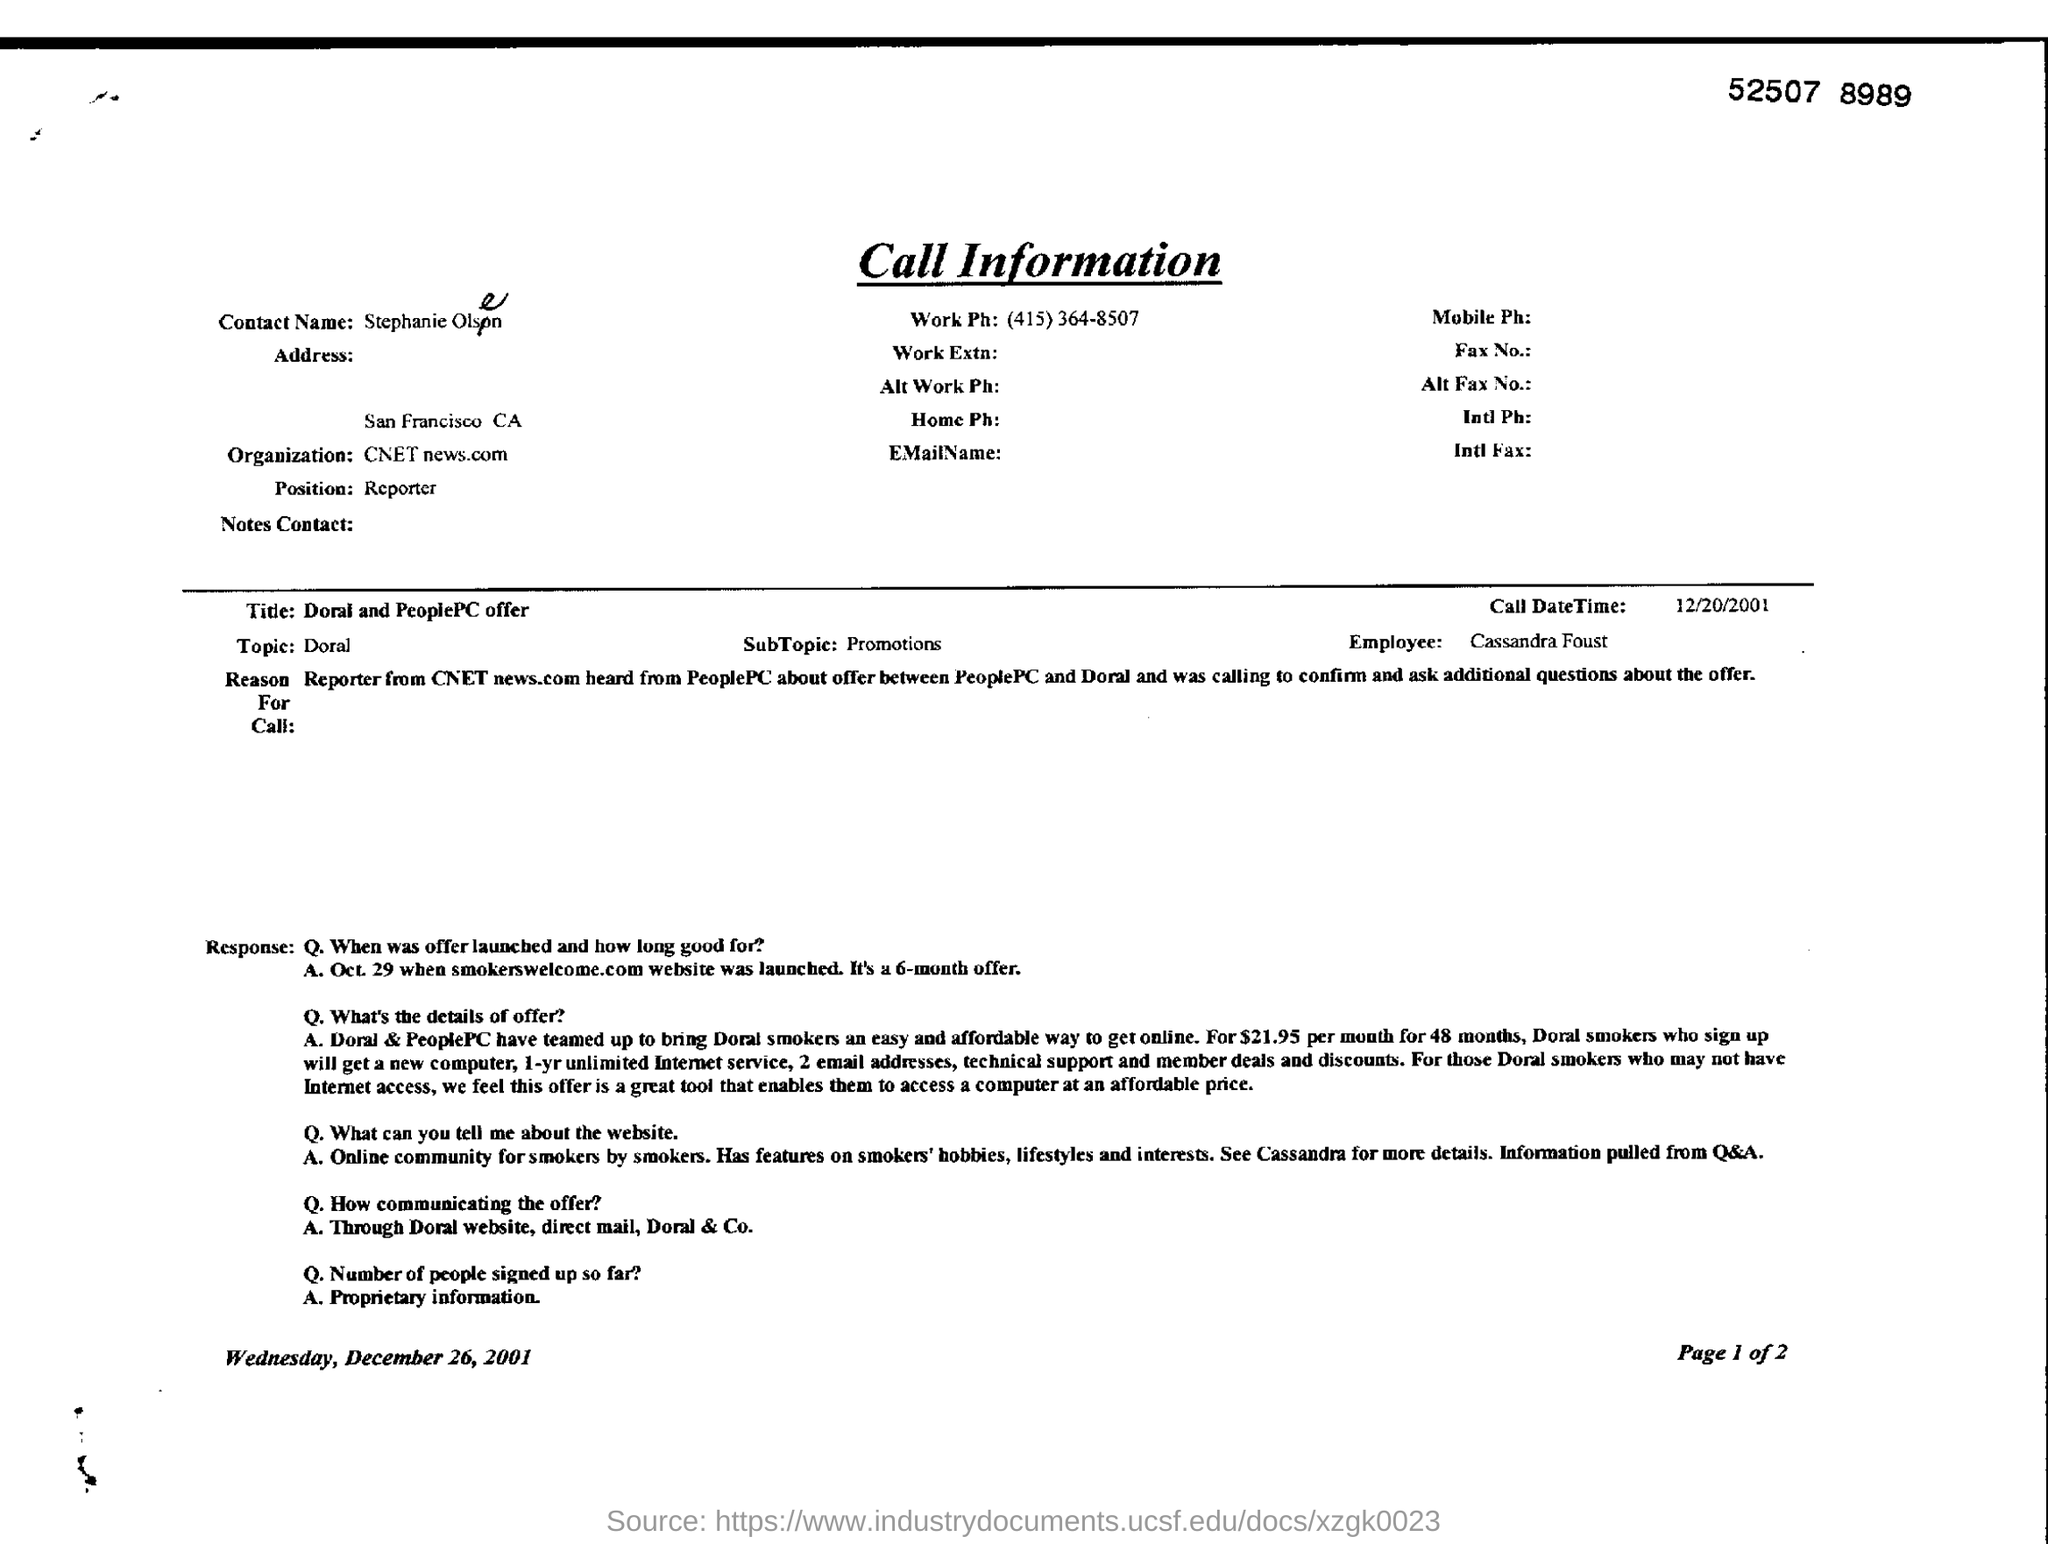Point out several critical features in this image. The topic at hand is Doral. The SubTopic is about Promotions. The contact name is Stephanie Olsen. The employee is Cassandra Foust. The position is that of a reporter. 